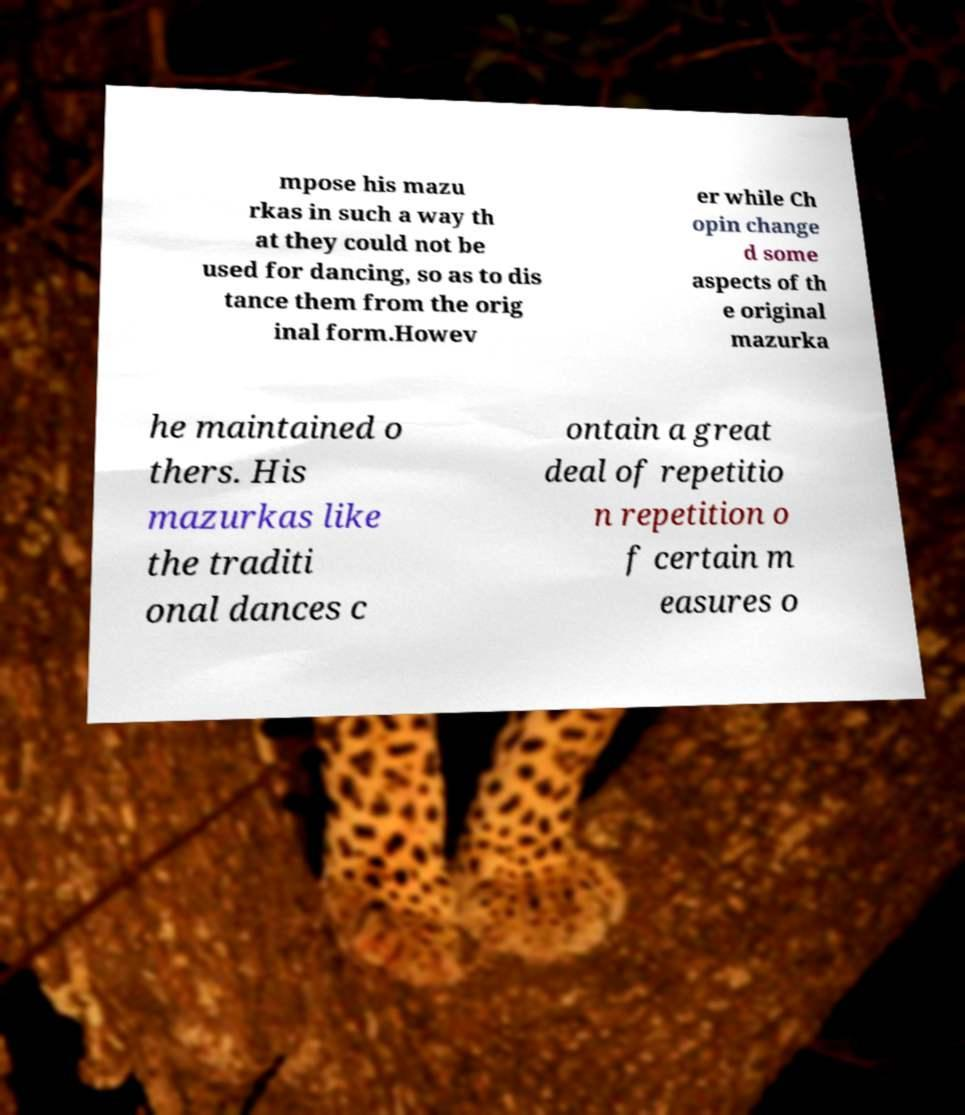I need the written content from this picture converted into text. Can you do that? mpose his mazu rkas in such a way th at they could not be used for dancing, so as to dis tance them from the orig inal form.Howev er while Ch opin change d some aspects of th e original mazurka he maintained o thers. His mazurkas like the traditi onal dances c ontain a great deal of repetitio n repetition o f certain m easures o 